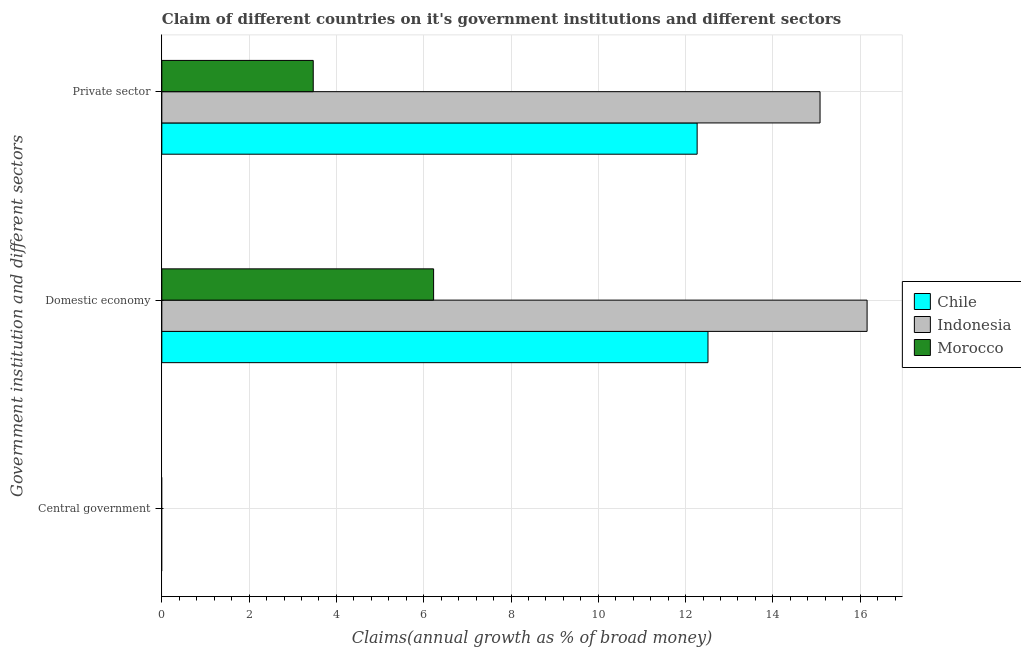How many different coloured bars are there?
Ensure brevity in your answer.  3. How many bars are there on the 1st tick from the top?
Make the answer very short. 3. What is the label of the 3rd group of bars from the top?
Your answer should be very brief. Central government. What is the percentage of claim on the domestic economy in Chile?
Your answer should be very brief. 12.51. Across all countries, what is the maximum percentage of claim on the private sector?
Make the answer very short. 15.08. Across all countries, what is the minimum percentage of claim on the domestic economy?
Provide a short and direct response. 6.23. In which country was the percentage of claim on the private sector maximum?
Offer a terse response. Indonesia. What is the total percentage of claim on the private sector in the graph?
Your answer should be compact. 30.81. What is the difference between the percentage of claim on the domestic economy in Indonesia and that in Chile?
Give a very brief answer. 3.65. What is the difference between the percentage of claim on the central government in Indonesia and the percentage of claim on the domestic economy in Chile?
Provide a succinct answer. -12.51. What is the average percentage of claim on the domestic economy per country?
Offer a terse response. 11.63. What is the difference between the percentage of claim on the domestic economy and percentage of claim on the private sector in Chile?
Your answer should be very brief. 0.25. In how many countries, is the percentage of claim on the domestic economy greater than 8 %?
Make the answer very short. 2. What is the ratio of the percentage of claim on the domestic economy in Chile to that in Morocco?
Provide a succinct answer. 2.01. Is the percentage of claim on the private sector in Indonesia less than that in Chile?
Ensure brevity in your answer.  No. What is the difference between the highest and the second highest percentage of claim on the private sector?
Give a very brief answer. 2.82. What is the difference between the highest and the lowest percentage of claim on the domestic economy?
Offer a very short reply. 9.93. Is it the case that in every country, the sum of the percentage of claim on the central government and percentage of claim on the domestic economy is greater than the percentage of claim on the private sector?
Your response must be concise. Yes. How many bars are there?
Ensure brevity in your answer.  6. Are all the bars in the graph horizontal?
Give a very brief answer. Yes. How many countries are there in the graph?
Your answer should be very brief. 3. What is the difference between two consecutive major ticks on the X-axis?
Offer a terse response. 2. How many legend labels are there?
Provide a succinct answer. 3. How are the legend labels stacked?
Your answer should be very brief. Vertical. What is the title of the graph?
Ensure brevity in your answer.  Claim of different countries on it's government institutions and different sectors. What is the label or title of the X-axis?
Your answer should be compact. Claims(annual growth as % of broad money). What is the label or title of the Y-axis?
Your answer should be very brief. Government institution and different sectors. What is the Claims(annual growth as % of broad money) in Chile in Domestic economy?
Offer a very short reply. 12.51. What is the Claims(annual growth as % of broad money) in Indonesia in Domestic economy?
Make the answer very short. 16.16. What is the Claims(annual growth as % of broad money) of Morocco in Domestic economy?
Offer a terse response. 6.23. What is the Claims(annual growth as % of broad money) in Chile in Private sector?
Ensure brevity in your answer.  12.26. What is the Claims(annual growth as % of broad money) in Indonesia in Private sector?
Your answer should be compact. 15.08. What is the Claims(annual growth as % of broad money) in Morocco in Private sector?
Make the answer very short. 3.47. Across all Government institution and different sectors, what is the maximum Claims(annual growth as % of broad money) of Chile?
Give a very brief answer. 12.51. Across all Government institution and different sectors, what is the maximum Claims(annual growth as % of broad money) of Indonesia?
Offer a terse response. 16.16. Across all Government institution and different sectors, what is the maximum Claims(annual growth as % of broad money) of Morocco?
Your answer should be very brief. 6.23. Across all Government institution and different sectors, what is the minimum Claims(annual growth as % of broad money) of Chile?
Your answer should be very brief. 0. Across all Government institution and different sectors, what is the minimum Claims(annual growth as % of broad money) in Indonesia?
Ensure brevity in your answer.  0. Across all Government institution and different sectors, what is the minimum Claims(annual growth as % of broad money) in Morocco?
Offer a very short reply. 0. What is the total Claims(annual growth as % of broad money) of Chile in the graph?
Your answer should be compact. 24.78. What is the total Claims(annual growth as % of broad money) in Indonesia in the graph?
Your response must be concise. 31.24. What is the total Claims(annual growth as % of broad money) in Morocco in the graph?
Your answer should be very brief. 9.7. What is the difference between the Claims(annual growth as % of broad money) in Chile in Domestic economy and that in Private sector?
Your response must be concise. 0.25. What is the difference between the Claims(annual growth as % of broad money) in Indonesia in Domestic economy and that in Private sector?
Offer a very short reply. 1.08. What is the difference between the Claims(annual growth as % of broad money) of Morocco in Domestic economy and that in Private sector?
Offer a very short reply. 2.76. What is the difference between the Claims(annual growth as % of broad money) in Chile in Domestic economy and the Claims(annual growth as % of broad money) in Indonesia in Private sector?
Keep it short and to the point. -2.57. What is the difference between the Claims(annual growth as % of broad money) in Chile in Domestic economy and the Claims(annual growth as % of broad money) in Morocco in Private sector?
Make the answer very short. 9.04. What is the difference between the Claims(annual growth as % of broad money) in Indonesia in Domestic economy and the Claims(annual growth as % of broad money) in Morocco in Private sector?
Offer a very short reply. 12.69. What is the average Claims(annual growth as % of broad money) in Chile per Government institution and different sectors?
Keep it short and to the point. 8.26. What is the average Claims(annual growth as % of broad money) of Indonesia per Government institution and different sectors?
Give a very brief answer. 10.41. What is the average Claims(annual growth as % of broad money) of Morocco per Government institution and different sectors?
Make the answer very short. 3.23. What is the difference between the Claims(annual growth as % of broad money) of Chile and Claims(annual growth as % of broad money) of Indonesia in Domestic economy?
Give a very brief answer. -3.65. What is the difference between the Claims(annual growth as % of broad money) of Chile and Claims(annual growth as % of broad money) of Morocco in Domestic economy?
Offer a terse response. 6.29. What is the difference between the Claims(annual growth as % of broad money) in Indonesia and Claims(annual growth as % of broad money) in Morocco in Domestic economy?
Your response must be concise. 9.93. What is the difference between the Claims(annual growth as % of broad money) of Chile and Claims(annual growth as % of broad money) of Indonesia in Private sector?
Ensure brevity in your answer.  -2.82. What is the difference between the Claims(annual growth as % of broad money) of Chile and Claims(annual growth as % of broad money) of Morocco in Private sector?
Provide a succinct answer. 8.8. What is the difference between the Claims(annual growth as % of broad money) in Indonesia and Claims(annual growth as % of broad money) in Morocco in Private sector?
Make the answer very short. 11.61. What is the ratio of the Claims(annual growth as % of broad money) in Chile in Domestic economy to that in Private sector?
Your response must be concise. 1.02. What is the ratio of the Claims(annual growth as % of broad money) of Indonesia in Domestic economy to that in Private sector?
Your answer should be compact. 1.07. What is the ratio of the Claims(annual growth as % of broad money) of Morocco in Domestic economy to that in Private sector?
Keep it short and to the point. 1.79. What is the difference between the highest and the lowest Claims(annual growth as % of broad money) of Chile?
Keep it short and to the point. 12.51. What is the difference between the highest and the lowest Claims(annual growth as % of broad money) in Indonesia?
Offer a terse response. 16.16. What is the difference between the highest and the lowest Claims(annual growth as % of broad money) in Morocco?
Make the answer very short. 6.23. 